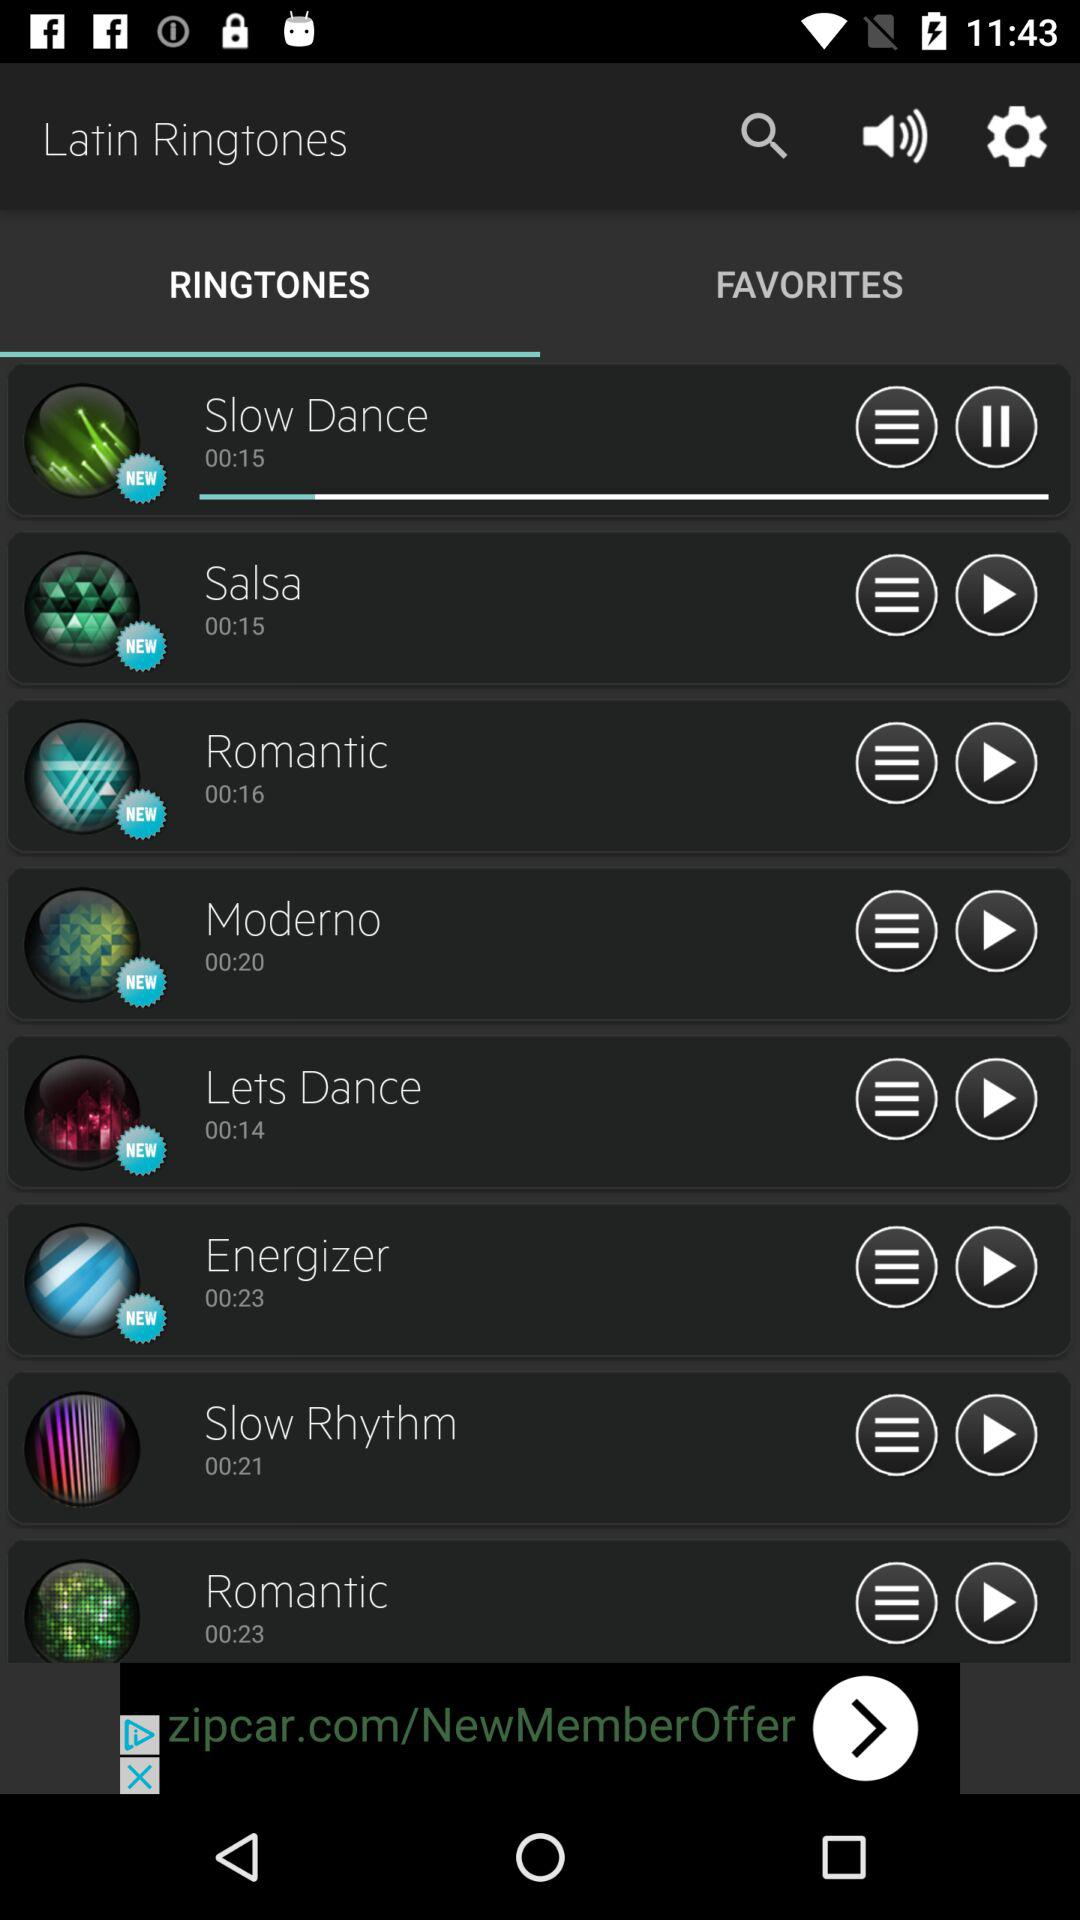Which ringtone is playing? The playing ringtone is "Slow Dance". 